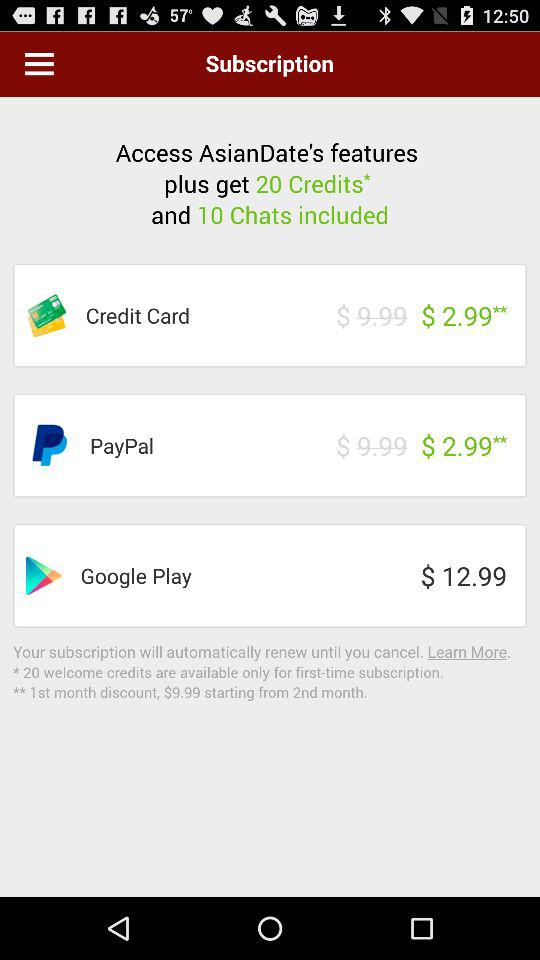What is the subscription price for PayPal? The subscription price for PayPal is $ 2.99**. 